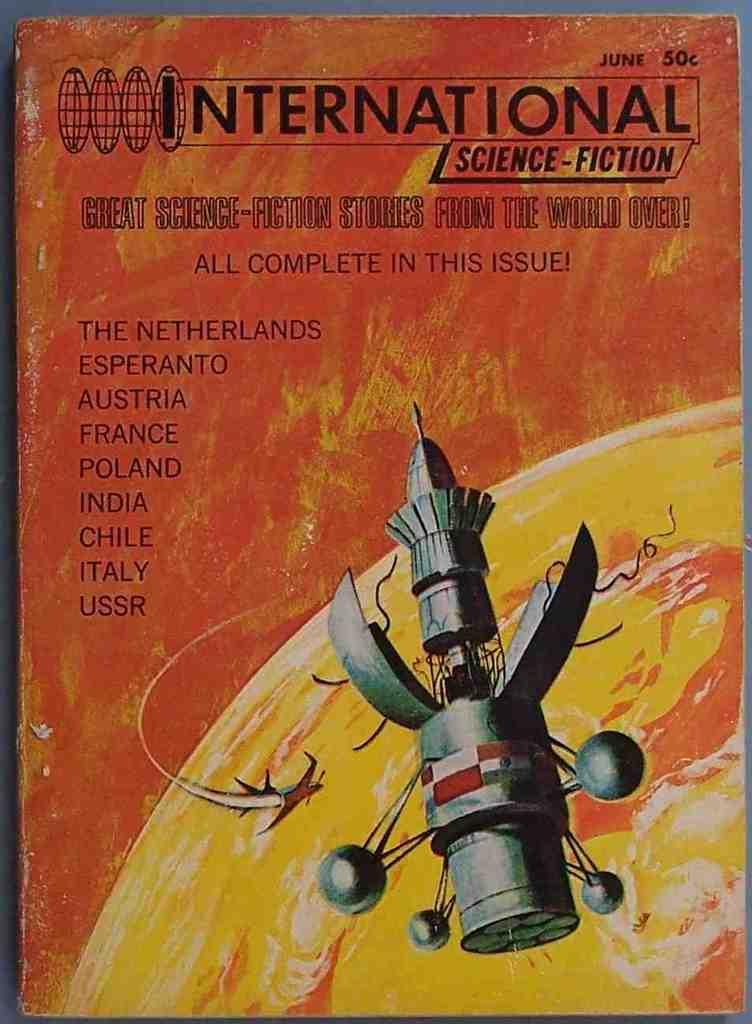<image>
Describe the image concisely. A book cover for International Science Fiction shows some wear. 